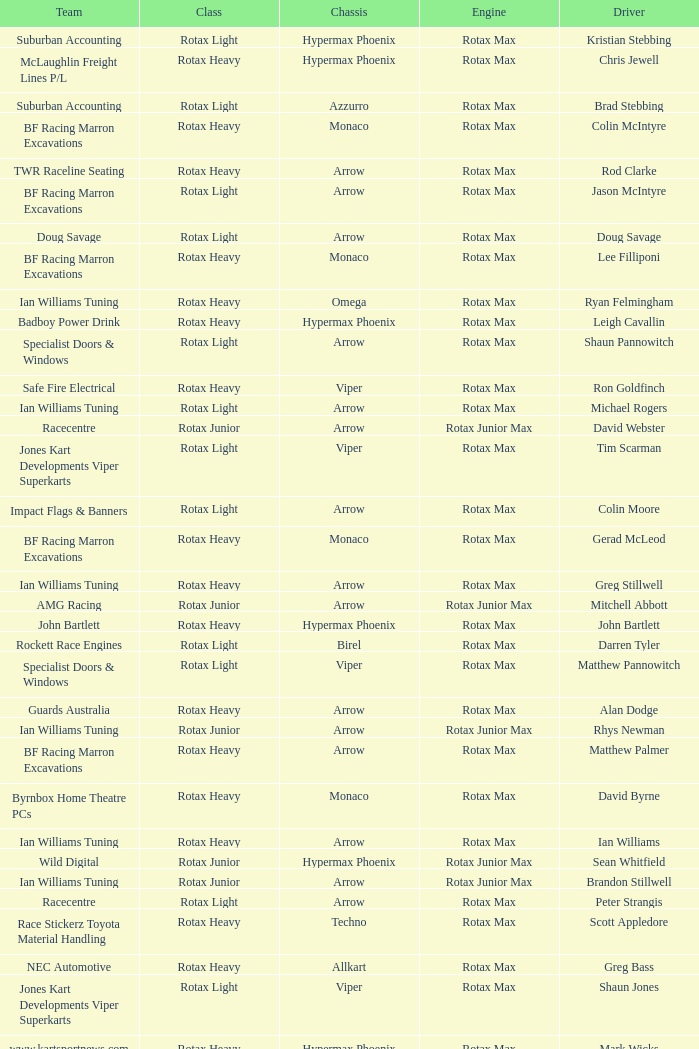What is the name of the team whose class is Rotax Light? Jones Kart Developments Viper Superkarts, Jones Kart Developments Viper Superkarts, BF Racing Marron Excavations, Ian Williams Tuning, Suburban Accounting, Suburban Accounting, Specialist Doors & Windows, Specialist Doors & Windows, Impact Flags & Banners, Rockett Race Engines, Racecentre, Doug Savage. 